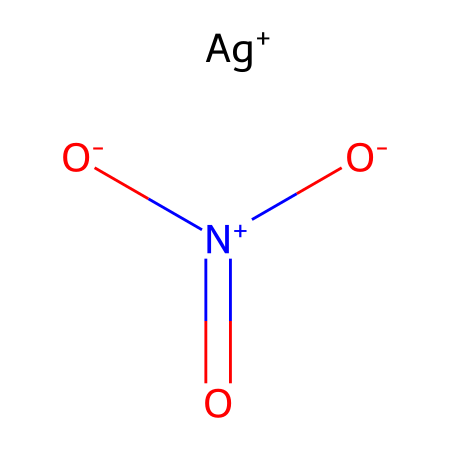What is the name of this chemical? The structure corresponds to silver nitrate, which is composed of silver (Ag) and nitrate ions.
Answer: silver nitrate How many nitrogen atoms are present in the chemical? The structure shows one nitrogen atom connected to three oxygen atoms as part of the nitrate group.
Answer: one How many oxygen atoms are in this chemical? The structure contains three oxygen atoms bonded to one nitrogen atom as part of the nitrate ion.
Answer: three What is the oxidation state of silver in this compound? Silver (Ag) has a +1 charge in the ionic representation shown in the structure.
Answer: +1 Which part of the chemical is responsible for the plating property? The silver ion (Ag+) is responsible for the metal plating property, as it is capable of depositing metallic silver onto surfaces.
Answer: Ag+ Why does silver nitrate dissolve in water? The ionic structure of silver nitrate allows it to dissociate into Ag+ and NO3- ions, which interact with water molecules and result in solubility.
Answer: ionic structure What would happen to this chemical when it is exposed to light? Silver nitrate is photosensitive and decomposes upon exposure to light, leading to the formation of silver particles, which can be seen in photographic processes.
Answer: decomposes 